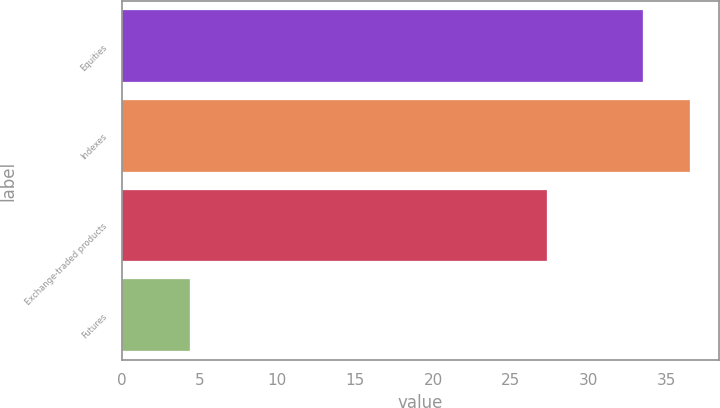Convert chart. <chart><loc_0><loc_0><loc_500><loc_500><bar_chart><fcel>Equities<fcel>Indexes<fcel>Exchange-traded products<fcel>Futures<nl><fcel>33.5<fcel>36.54<fcel>27.3<fcel>4.4<nl></chart> 